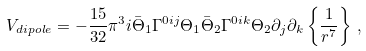Convert formula to latex. <formula><loc_0><loc_0><loc_500><loc_500>V _ { d i p o l e } = - { \frac { 1 5 } { 3 2 } } \pi ^ { 3 } i \bar { \Theta } _ { 1 } \Gamma ^ { 0 i j } \Theta _ { 1 } \bar { \Theta } _ { 2 } \Gamma ^ { 0 i k } \Theta _ { 2 } \partial _ { j } \partial _ { k } \left \{ { \frac { 1 } { r ^ { 7 } } } \right \} \, ,</formula> 